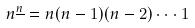<formula> <loc_0><loc_0><loc_500><loc_500>n ^ { \underline { n } } = n ( n - 1 ) ( n - 2 ) \cdot \cdot \cdot 1</formula> 